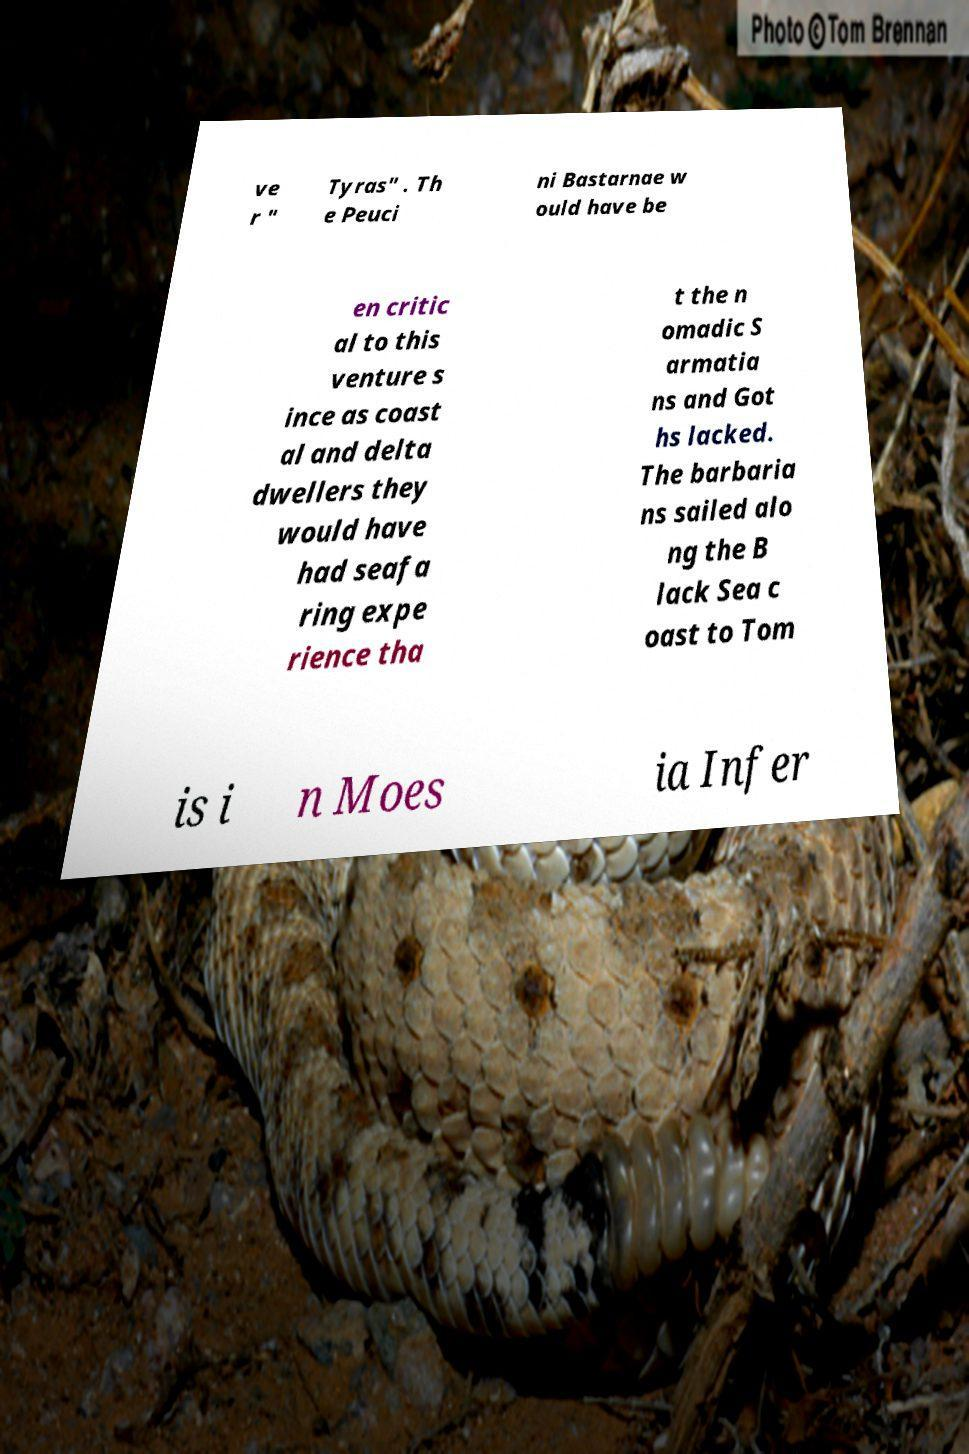Could you extract and type out the text from this image? ve r " Tyras" . Th e Peuci ni Bastarnae w ould have be en critic al to this venture s ince as coast al and delta dwellers they would have had seafa ring expe rience tha t the n omadic S armatia ns and Got hs lacked. The barbaria ns sailed alo ng the B lack Sea c oast to Tom is i n Moes ia Infer 